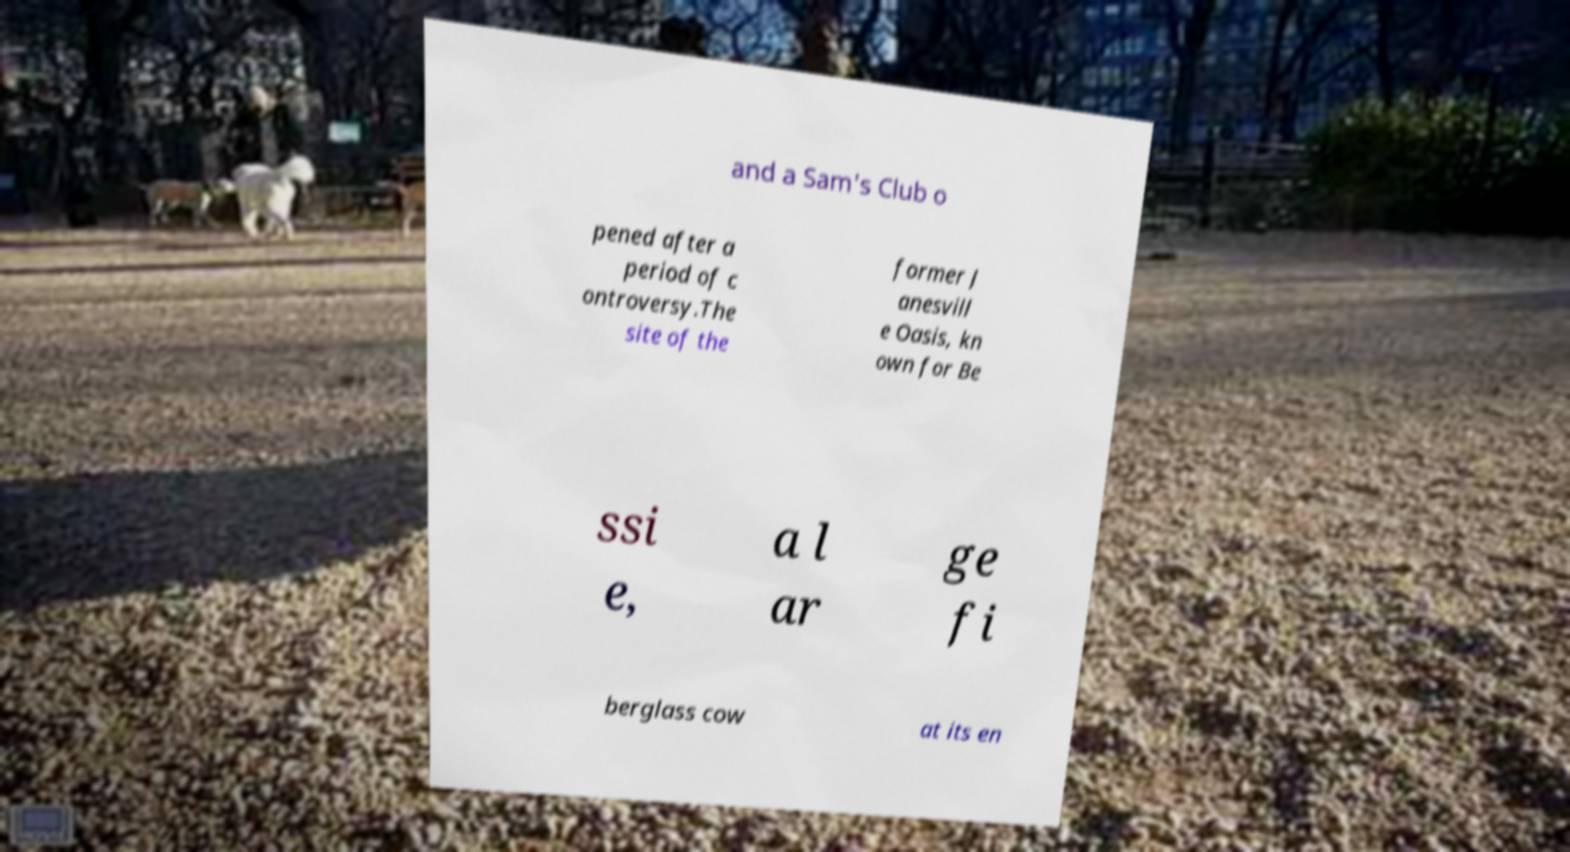Can you read and provide the text displayed in the image?This photo seems to have some interesting text. Can you extract and type it out for me? and a Sam's Club o pened after a period of c ontroversy.The site of the former J anesvill e Oasis, kn own for Be ssi e, a l ar ge fi berglass cow at its en 